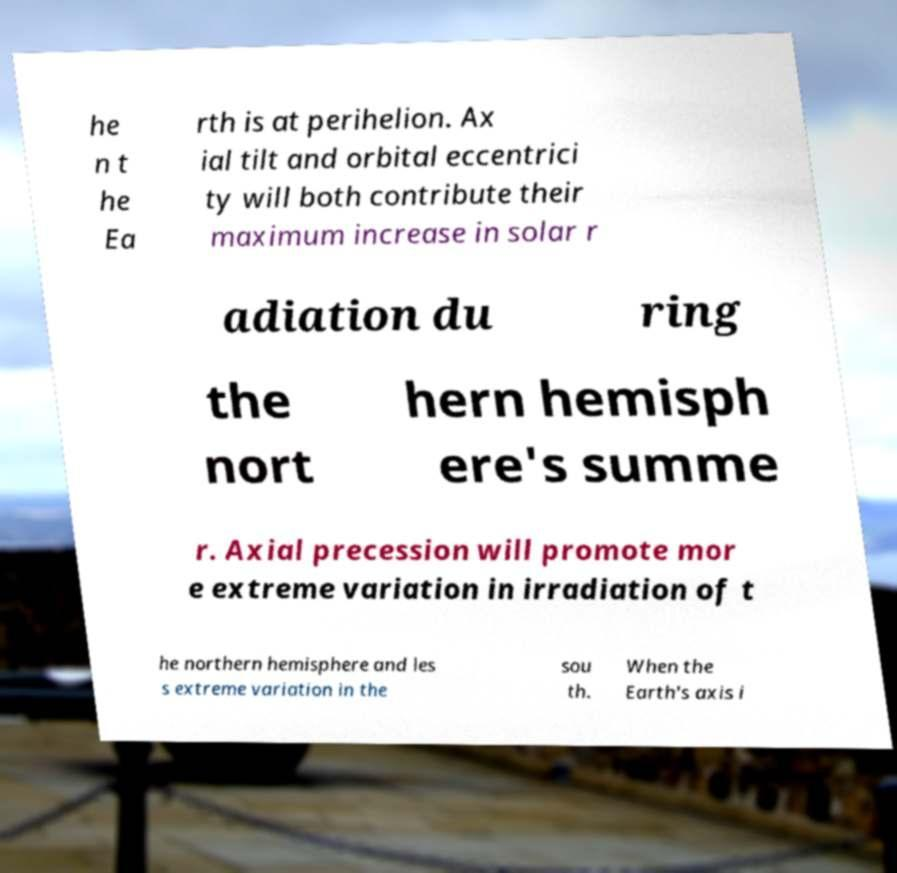There's text embedded in this image that I need extracted. Can you transcribe it verbatim? he n t he Ea rth is at perihelion. Ax ial tilt and orbital eccentrici ty will both contribute their maximum increase in solar r adiation du ring the nort hern hemisph ere's summe r. Axial precession will promote mor e extreme variation in irradiation of t he northern hemisphere and les s extreme variation in the sou th. When the Earth's axis i 